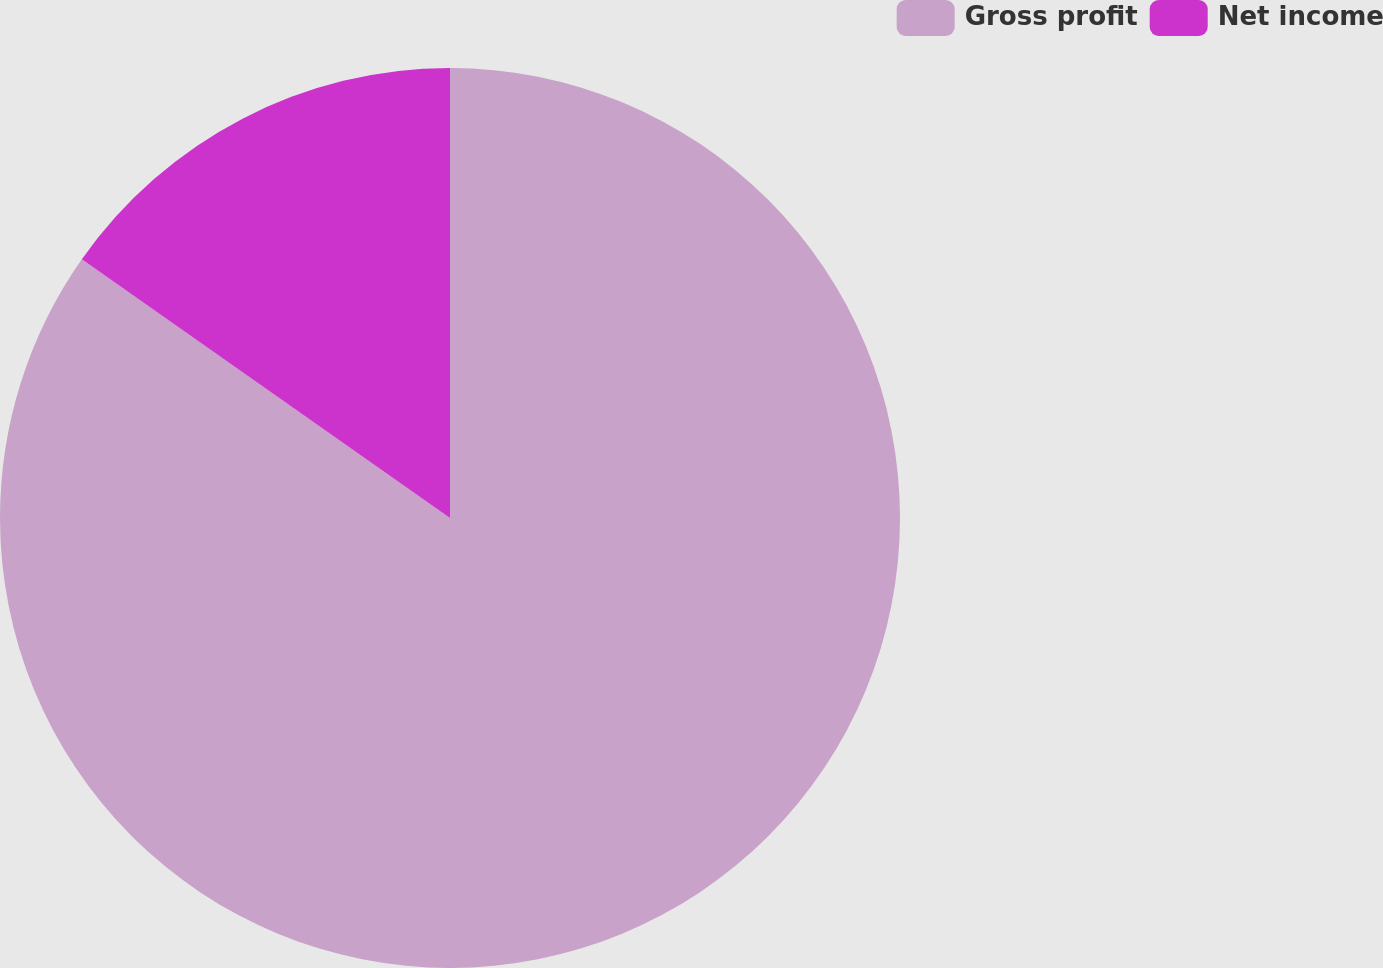Convert chart to OTSL. <chart><loc_0><loc_0><loc_500><loc_500><pie_chart><fcel>Gross profit<fcel>Net income<nl><fcel>84.75%<fcel>15.25%<nl></chart> 